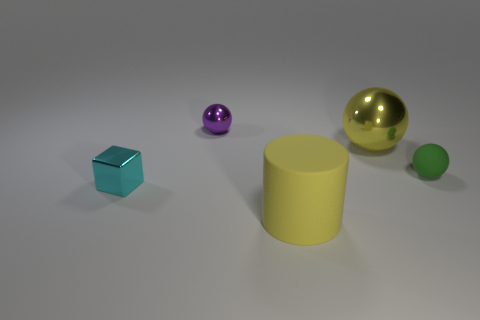Add 1 tiny green shiny cylinders. How many objects exist? 6 Subtract all cubes. How many objects are left? 4 Subtract 1 cyan blocks. How many objects are left? 4 Subtract all small green rubber objects. Subtract all big yellow balls. How many objects are left? 3 Add 4 big metallic balls. How many big metallic balls are left? 5 Add 5 metallic spheres. How many metallic spheres exist? 7 